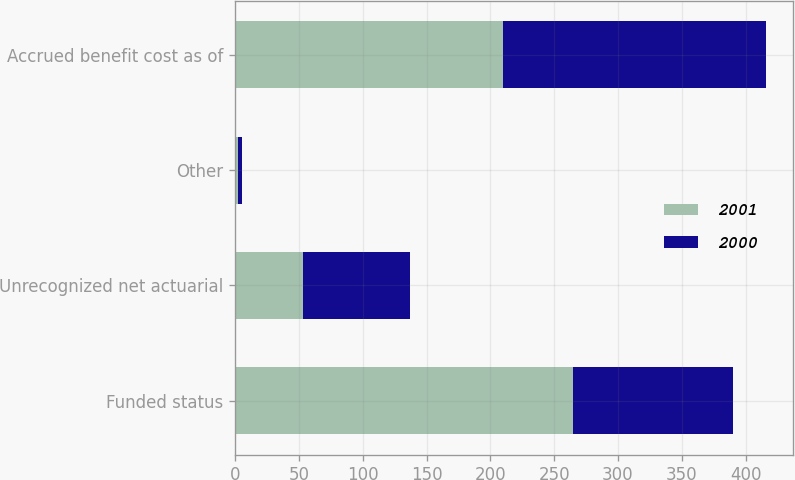Convert chart. <chart><loc_0><loc_0><loc_500><loc_500><stacked_bar_chart><ecel><fcel>Funded status<fcel>Unrecognized net actuarial<fcel>Other<fcel>Accrued benefit cost as of<nl><fcel>2001<fcel>265<fcel>53<fcel>2<fcel>210<nl><fcel>2000<fcel>125<fcel>84<fcel>3<fcel>206<nl></chart> 